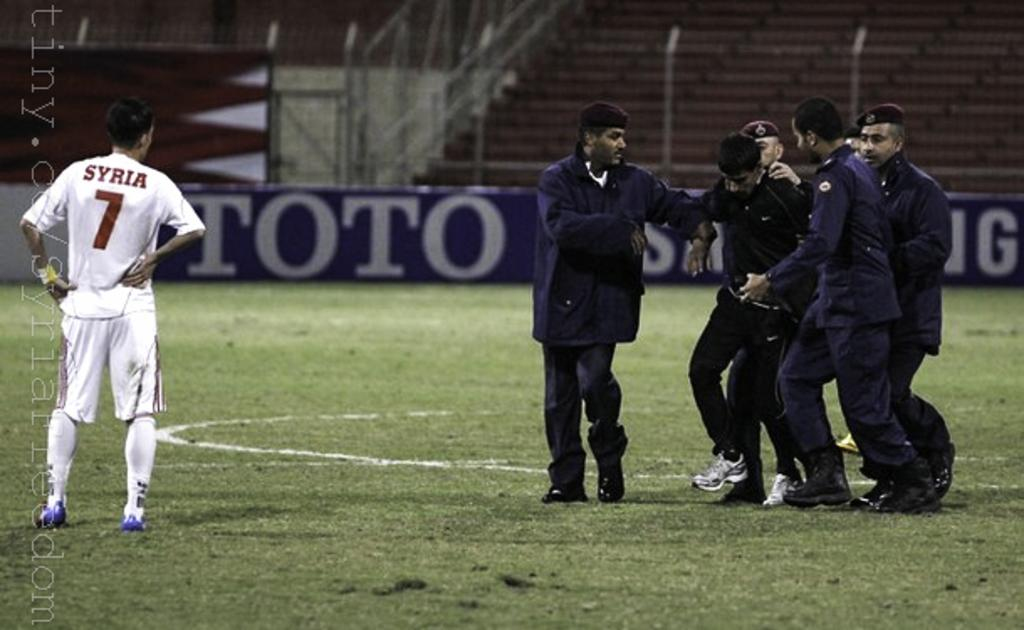<image>
Offer a succinct explanation of the picture presented. A soccer player in a Syria jersey watches someone getting helped off of the field. 